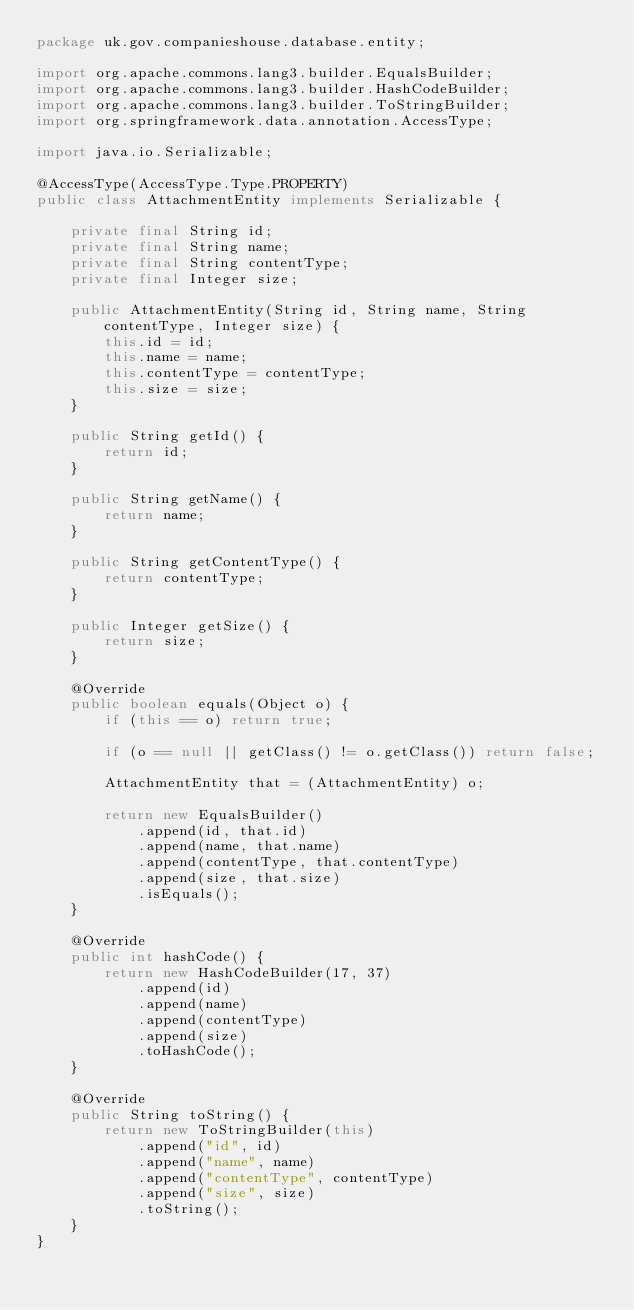<code> <loc_0><loc_0><loc_500><loc_500><_Java_>package uk.gov.companieshouse.database.entity;

import org.apache.commons.lang3.builder.EqualsBuilder;
import org.apache.commons.lang3.builder.HashCodeBuilder;
import org.apache.commons.lang3.builder.ToStringBuilder;
import org.springframework.data.annotation.AccessType;

import java.io.Serializable;

@AccessType(AccessType.Type.PROPERTY)
public class AttachmentEntity implements Serializable {

    private final String id;
    private final String name;
    private final String contentType;
    private final Integer size;

    public AttachmentEntity(String id, String name, String contentType, Integer size) {
        this.id = id;
        this.name = name;
        this.contentType = contentType;
        this.size = size;
    }

    public String getId() {
        return id;
    }

    public String getName() {
        return name;
    }

    public String getContentType() {
        return contentType;
    }

    public Integer getSize() {
        return size;
    }

    @Override
    public boolean equals(Object o) {
        if (this == o) return true;

        if (o == null || getClass() != o.getClass()) return false;

        AttachmentEntity that = (AttachmentEntity) o;

        return new EqualsBuilder()
            .append(id, that.id)
            .append(name, that.name)
            .append(contentType, that.contentType)
            .append(size, that.size)
            .isEquals();
    }

    @Override
    public int hashCode() {
        return new HashCodeBuilder(17, 37)
            .append(id)
            .append(name)
            .append(contentType)
            .append(size)
            .toHashCode();
    }

    @Override
    public String toString() {
        return new ToStringBuilder(this)
            .append("id", id)
            .append("name", name)
            .append("contentType", contentType)
            .append("size", size)
            .toString();
    }
}
</code> 